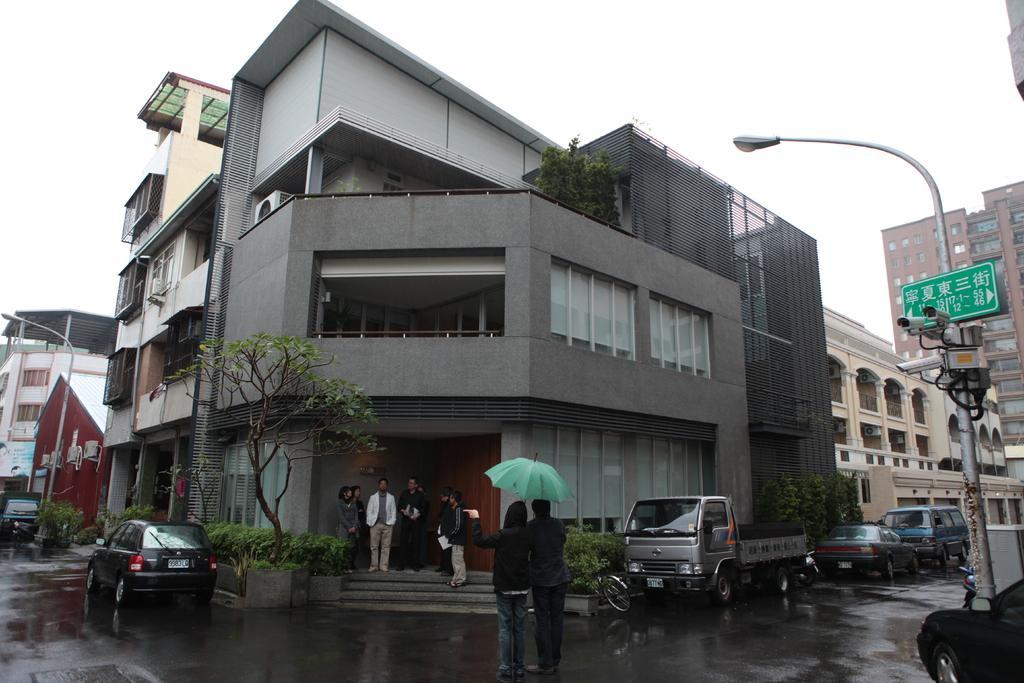Please provide a concise description of this image. In this image we can see a building, here is the glass window, here are the persons standing, here is the tree, here are the two persons holding an umbrella in the hand, here is a vehicle on the road, here is the street light, here is the pole, at above here is the sky. 